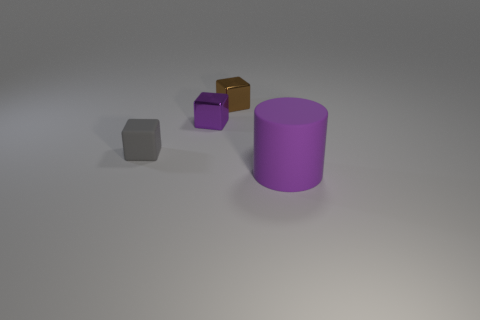Are there any other things that have the same shape as the big purple matte thing?
Ensure brevity in your answer.  No. Are there any other things that are the same size as the purple rubber cylinder?
Your answer should be compact. No. Does the small rubber thing have the same shape as the tiny purple shiny thing?
Provide a succinct answer. Yes. Are there fewer tiny matte things that are in front of the gray matte thing than large cylinders that are in front of the purple metallic cube?
Provide a succinct answer. Yes. What number of cylinders are on the left side of the brown cube?
Make the answer very short. 0. There is a matte thing on the left side of the big purple object; does it have the same shape as the tiny shiny object on the right side of the purple block?
Keep it short and to the point. Yes. What number of other objects are the same color as the big cylinder?
Provide a succinct answer. 1. The purple thing that is on the left side of the purple object to the right of the small cube that is right of the small purple object is made of what material?
Offer a terse response. Metal. There is a small thing behind the small purple block that is on the right side of the gray thing; what is its material?
Offer a terse response. Metal. Is the number of large purple things that are on the left side of the large thing less than the number of purple matte objects?
Your answer should be compact. Yes. 